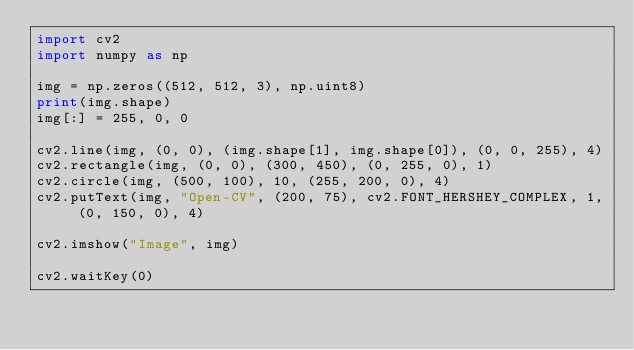Convert code to text. <code><loc_0><loc_0><loc_500><loc_500><_Python_>import cv2
import numpy as np

img = np.zeros((512, 512, 3), np.uint8)
print(img.shape)
img[:] = 255, 0, 0

cv2.line(img, (0, 0), (img.shape[1], img.shape[0]), (0, 0, 255), 4)
cv2.rectangle(img, (0, 0), (300, 450), (0, 255, 0), 1)
cv2.circle(img, (500, 100), 10, (255, 200, 0), 4)
cv2.putText(img, "Open-CV", (200, 75), cv2.FONT_HERSHEY_COMPLEX, 1, (0, 150, 0), 4)

cv2.imshow("Image", img)

cv2.waitKey(0)</code> 